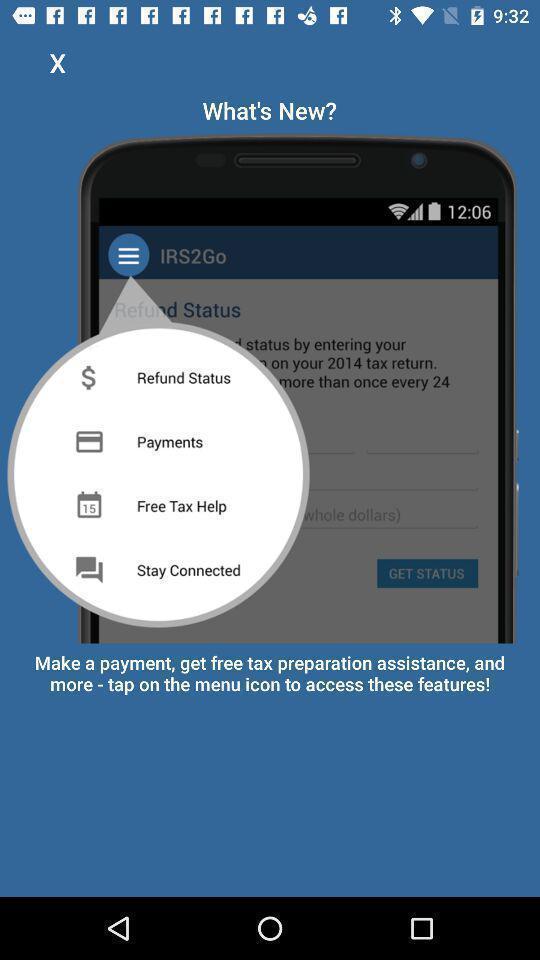Explain what's happening in this screen capture. Screen page shows about a new app. 